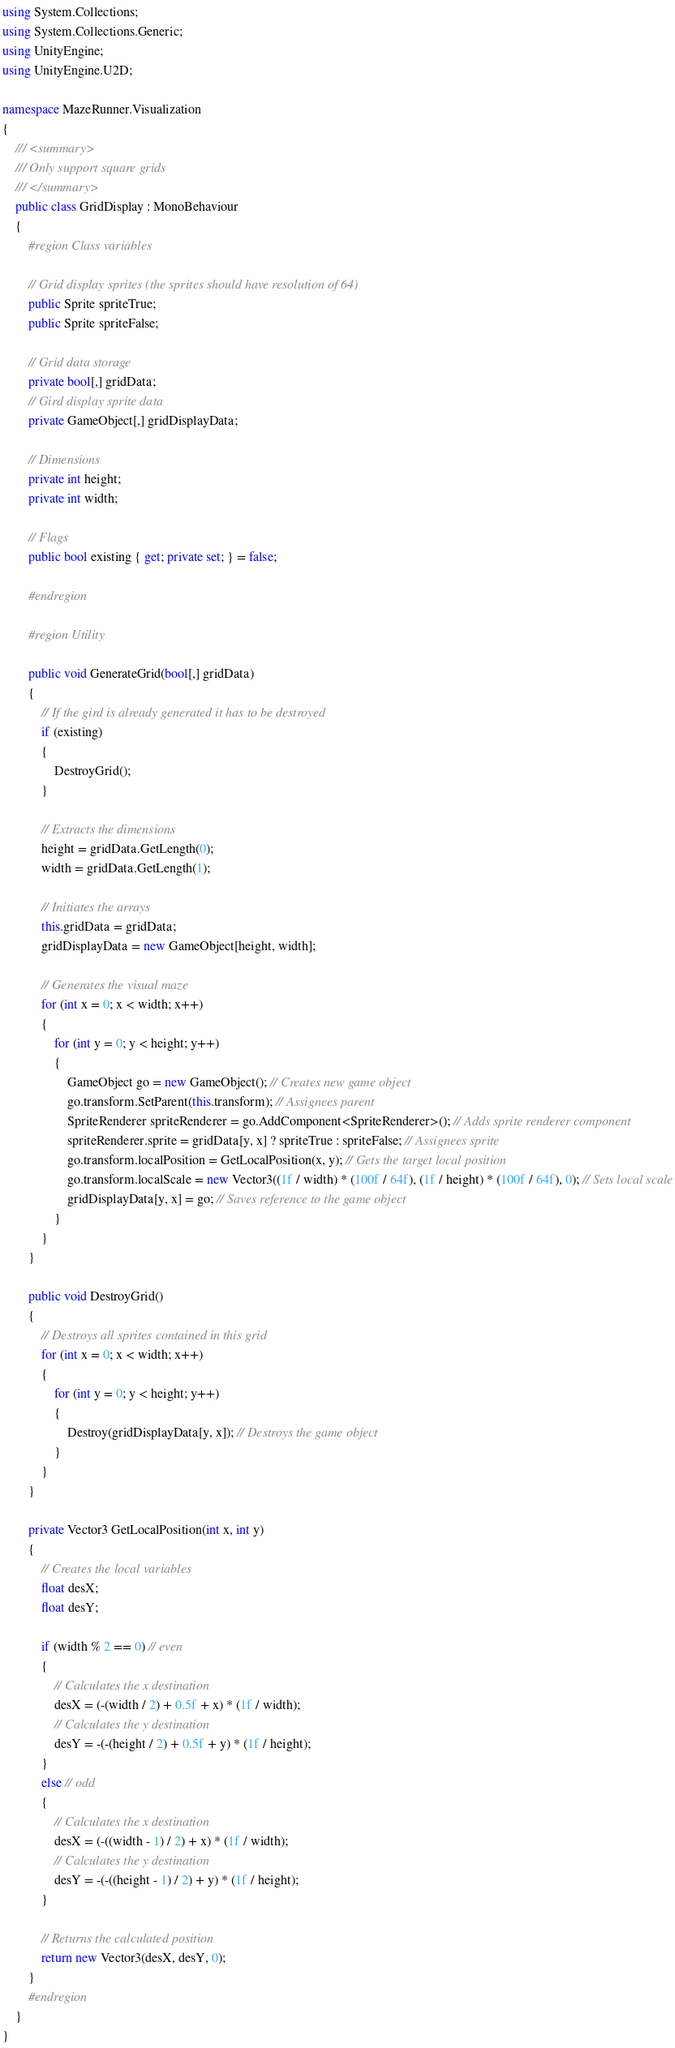<code> <loc_0><loc_0><loc_500><loc_500><_C#_>using System.Collections;
using System.Collections.Generic;
using UnityEngine;
using UnityEngine.U2D;

namespace MazeRunner.Visualization
{
    /// <summary>
    /// Only support square grids
    /// </summary>
    public class GridDisplay : MonoBehaviour
    {
        #region Class variables

        // Grid display sprites (the sprites should have resolution of 64)
        public Sprite spriteTrue;
        public Sprite spriteFalse;

        // Grid data storage
        private bool[,] gridData;
        // Gird display sprite data
        private GameObject[,] gridDisplayData;

        // Dimensions
        private int height;
        private int width;

        // Flags
        public bool existing { get; private set; } = false;

        #endregion

        #region Utility

        public void GenerateGrid(bool[,] gridData)
        {
            // If the gird is already generated it has to be destroyed
            if (existing)
            {
                DestroyGrid();
            }

            // Extracts the dimensions
            height = gridData.GetLength(0);
            width = gridData.GetLength(1);

            // Initiates the arrays
            this.gridData = gridData;
            gridDisplayData = new GameObject[height, width];

            // Generates the visual maze
            for (int x = 0; x < width; x++)
            {
                for (int y = 0; y < height; y++)
                {
                    GameObject go = new GameObject(); // Creates new game object
                    go.transform.SetParent(this.transform); // Assignees parent
                    SpriteRenderer spriteRenderer = go.AddComponent<SpriteRenderer>(); // Adds sprite renderer component
                    spriteRenderer.sprite = gridData[y, x] ? spriteTrue : spriteFalse; // Assignees sprite
                    go.transform.localPosition = GetLocalPosition(x, y); // Gets the target local position
                    go.transform.localScale = new Vector3((1f / width) * (100f / 64f), (1f / height) * (100f / 64f), 0); // Sets local scale
                    gridDisplayData[y, x] = go; // Saves reference to the game object
                }
            }
        }

        public void DestroyGrid()
        {
            // Destroys all sprites contained in this grid
            for (int x = 0; x < width; x++)
            {
                for (int y = 0; y < height; y++)
                {
                    Destroy(gridDisplayData[y, x]); // Destroys the game object
                }
            }
        }

        private Vector3 GetLocalPosition(int x, int y)
        {
            // Creates the local variables
            float desX;
            float desY;

            if (width % 2 == 0) // even
            {
                // Calculates the x destination
                desX = (-(width / 2) + 0.5f + x) * (1f / width);
                // Calculates the y destination
                desY = -(-(height / 2) + 0.5f + y) * (1f / height);
            }
            else // odd
            {
                // Calculates the x destination
                desX = (-((width - 1) / 2) + x) * (1f / width);
                // Calculates the y destination
                desY = -(-((height - 1) / 2) + y) * (1f / height);
            }

            // Returns the calculated position
            return new Vector3(desX, desY, 0);
        }
        #endregion
    }
} 

</code> 